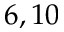Convert formula to latex. <formula><loc_0><loc_0><loc_500><loc_500>6 , 1 0</formula> 